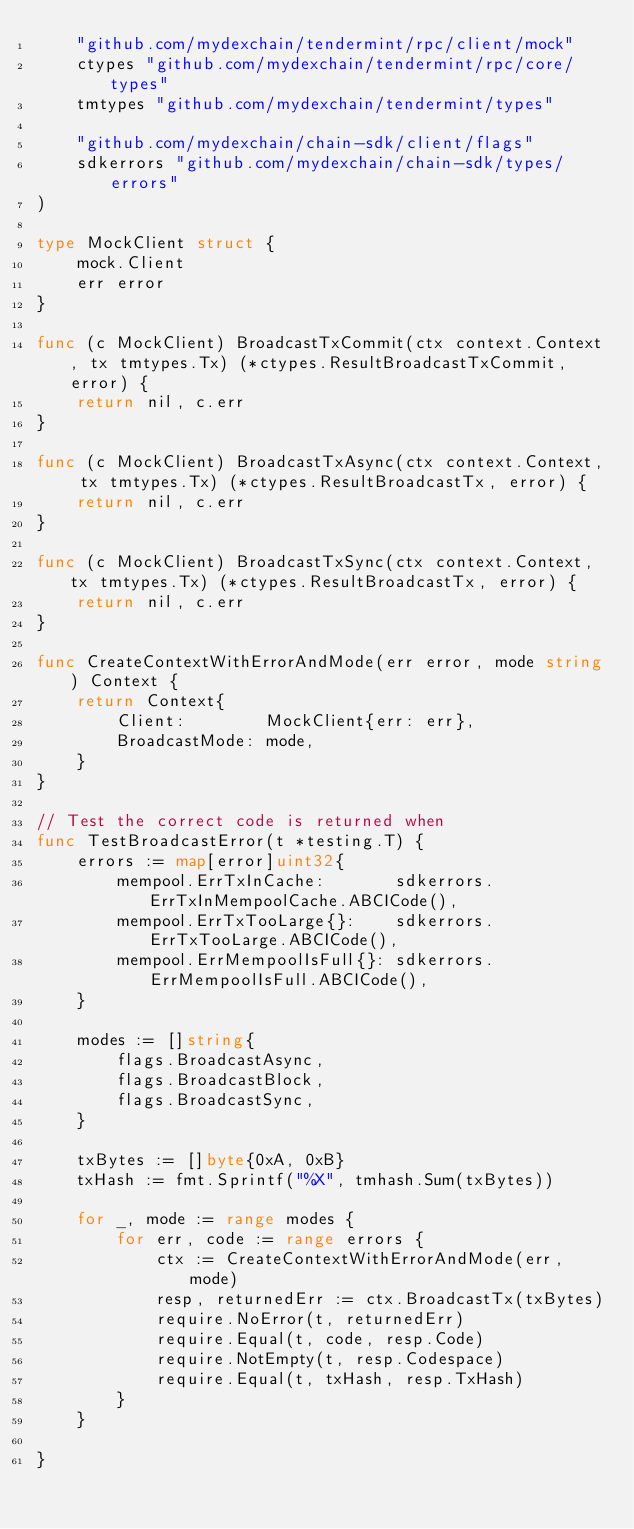<code> <loc_0><loc_0><loc_500><loc_500><_Go_>	"github.com/mydexchain/tendermint/rpc/client/mock"
	ctypes "github.com/mydexchain/tendermint/rpc/core/types"
	tmtypes "github.com/mydexchain/tendermint/types"

	"github.com/mydexchain/chain-sdk/client/flags"
	sdkerrors "github.com/mydexchain/chain-sdk/types/errors"
)

type MockClient struct {
	mock.Client
	err error
}

func (c MockClient) BroadcastTxCommit(ctx context.Context, tx tmtypes.Tx) (*ctypes.ResultBroadcastTxCommit, error) {
	return nil, c.err
}

func (c MockClient) BroadcastTxAsync(ctx context.Context, tx tmtypes.Tx) (*ctypes.ResultBroadcastTx, error) {
	return nil, c.err
}

func (c MockClient) BroadcastTxSync(ctx context.Context, tx tmtypes.Tx) (*ctypes.ResultBroadcastTx, error) {
	return nil, c.err
}

func CreateContextWithErrorAndMode(err error, mode string) Context {
	return Context{
		Client:        MockClient{err: err},
		BroadcastMode: mode,
	}
}

// Test the correct code is returned when
func TestBroadcastError(t *testing.T) {
	errors := map[error]uint32{
		mempool.ErrTxInCache:       sdkerrors.ErrTxInMempoolCache.ABCICode(),
		mempool.ErrTxTooLarge{}:    sdkerrors.ErrTxTooLarge.ABCICode(),
		mempool.ErrMempoolIsFull{}: sdkerrors.ErrMempoolIsFull.ABCICode(),
	}

	modes := []string{
		flags.BroadcastAsync,
		flags.BroadcastBlock,
		flags.BroadcastSync,
	}

	txBytes := []byte{0xA, 0xB}
	txHash := fmt.Sprintf("%X", tmhash.Sum(txBytes))

	for _, mode := range modes {
		for err, code := range errors {
			ctx := CreateContextWithErrorAndMode(err, mode)
			resp, returnedErr := ctx.BroadcastTx(txBytes)
			require.NoError(t, returnedErr)
			require.Equal(t, code, resp.Code)
			require.NotEmpty(t, resp.Codespace)
			require.Equal(t, txHash, resp.TxHash)
		}
	}

}
</code> 